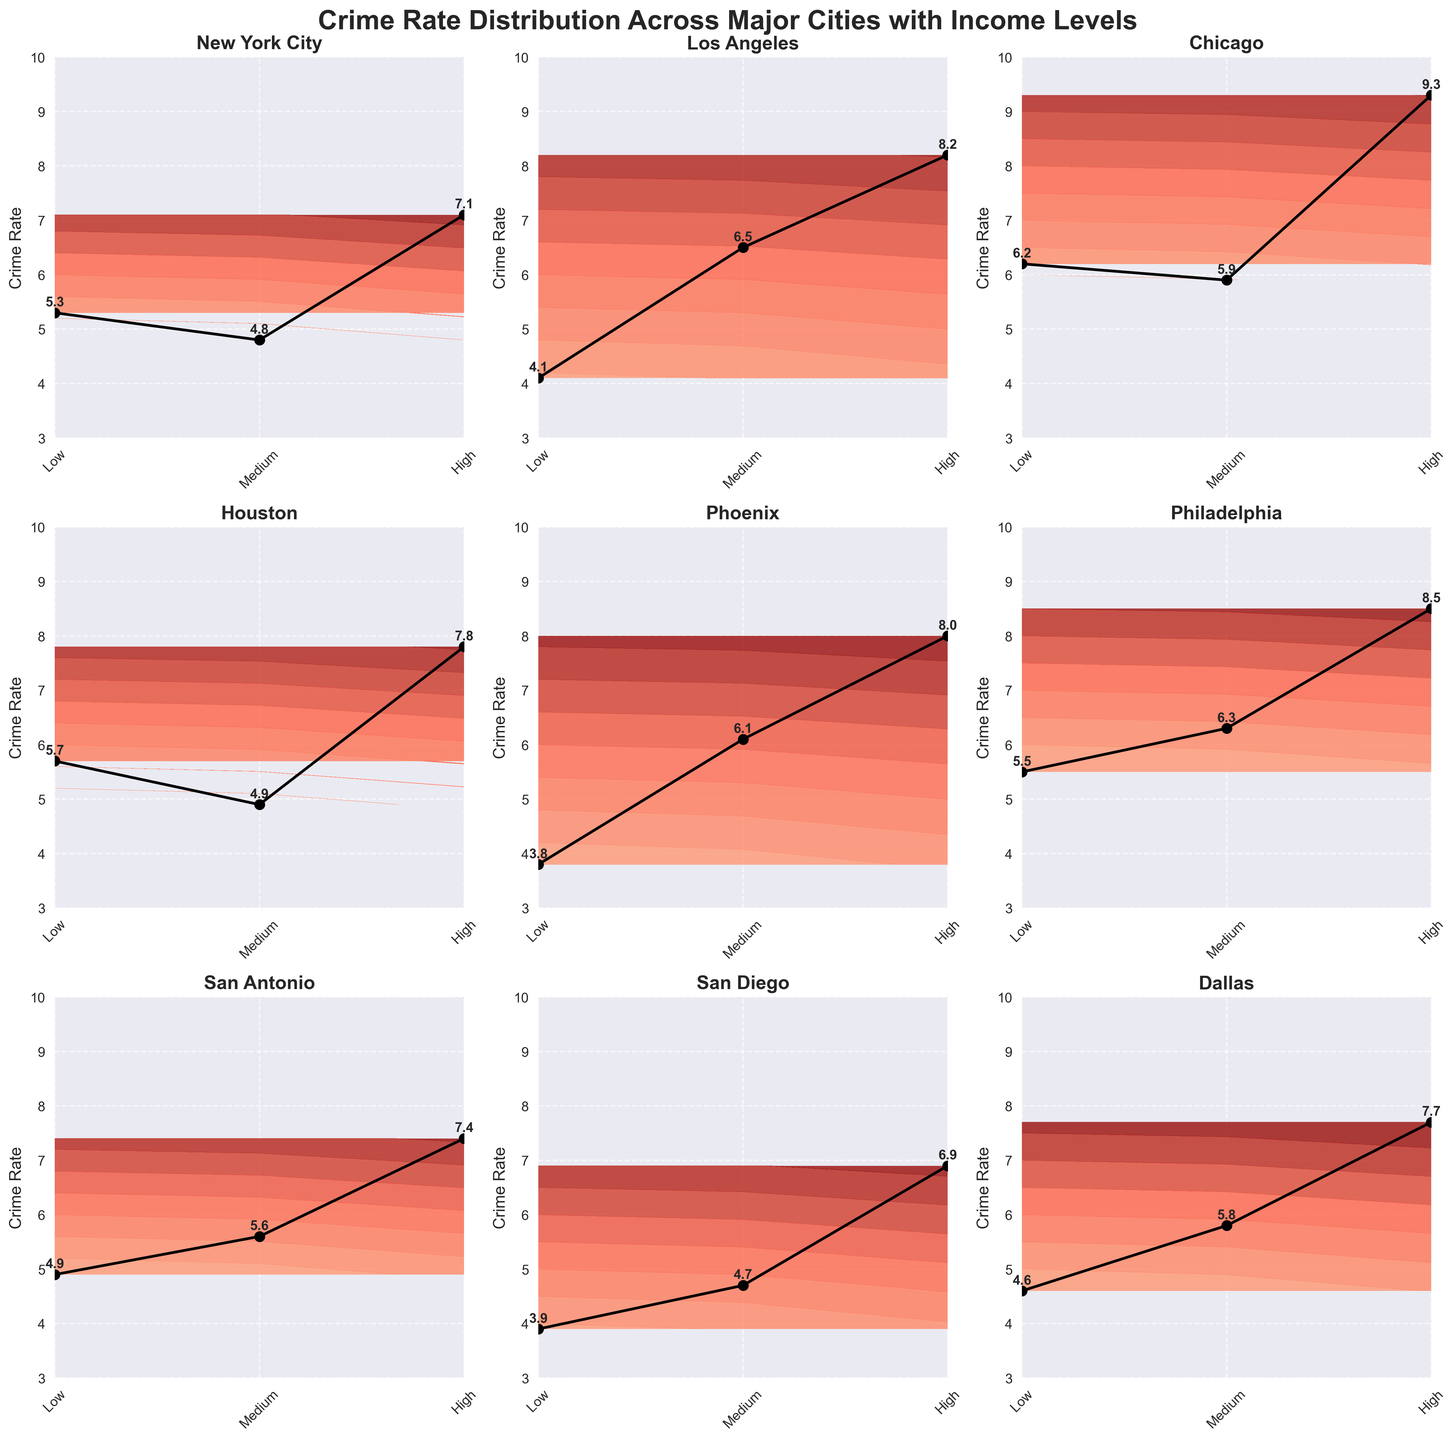What's the title of the figure? The title is displayed at the top of the figure and reads: "Crime Rate Distribution Across Major Cities with Income Levels".
Answer: Crime Rate Distribution Across Major Cities with Income Levels How many cities are compared in the figure? By counting the number of subplots, each labeled with a city name, we see that there are 9 cities.
Answer: 9 Which city shows the highest crime rate in the Low-income level? Looking at the data points in the contour plots, Philadelphia has the highest crime rate in the Low-income level, with 8.5.
Answer: Philadelphia Which city has the lowest crime rate in the High-income level? From the contour plots, San Diego shows the lowest crime rate in the High-income level at 3.9.
Answer: San Diego What is the general trend between income levels and crime rates? Observing the contour plots across all cities, the crime rate generally increases as the income level decreases.
Answer: Crime rate increases as income level decreases Which cities have a crime rate of 7 or above in the Medium-income level? Analyzing the plots, Los Angeles (6.5), Phoenix (6.1), and Philadelphia (6.3) are closest to 7, but none reach or exceed it. Thus, none of the cities meet the criteria.
Answer: None Compare the crime rate between Chicago and Dallas in the Low-income level. Which city has a higher rate? In the Low-income level, Chicago has a crime rate of 9.3, while Dallas has 7.7. Therefore, Chicago has a higher rate.
Answer: Chicago Which city shows the smallest difference between the High and Low-income crime rates? Calculating the differences: New York City (7.1 - 5.3 = 1.8), Los Angeles (8.2 - 4.1 = 4.1), Chicago (9.3 - 6.2 = 3.1), Houston (7.8 - 5.7 = 2.1), Phoenix (8.0 - 3.8 = 4.2), Philadelphia (8.5 - 5.5 = 3.0), San Antonio (7.4 - 4.9 = 2.5), San Diego (6.9 - 3.9 = 3.0), Dallas (7.7 - 4.6 = 3.1). New York City has the smallest difference of 1.8.
Answer: New York City What's the median crime rate value for Philadelphia across all income levels? Philadelphia's crime rates are 8.5 (Low), 6.3 (Medium), and 5.5 (High). Arranging these values: 5.5, 6.3, 8.5, the median value is the middle number, 6.3.
Answer: 6.3 Identify a city with a consistently low crime rate across all income levels. Observing the plots, San Diego consistently maintains lower crime rates: 6.9 (Low), 4.7 (Medium), and 3.9 (High).
Answer: San Diego 